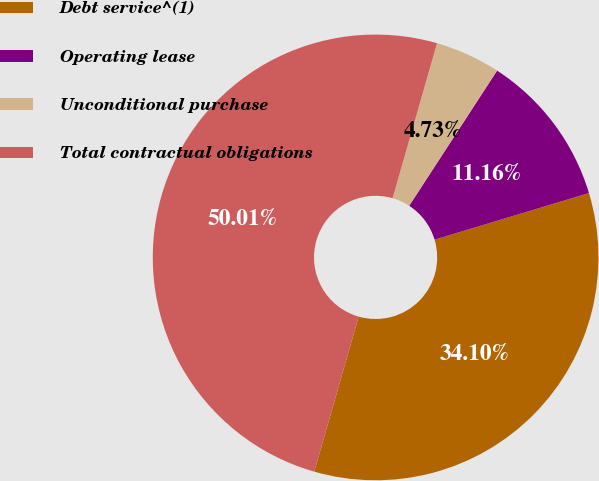Convert chart. <chart><loc_0><loc_0><loc_500><loc_500><pie_chart><fcel>Debt service^(1)<fcel>Operating lease<fcel>Unconditional purchase<fcel>Total contractual obligations<nl><fcel>34.1%<fcel>11.16%<fcel>4.73%<fcel>50.0%<nl></chart> 